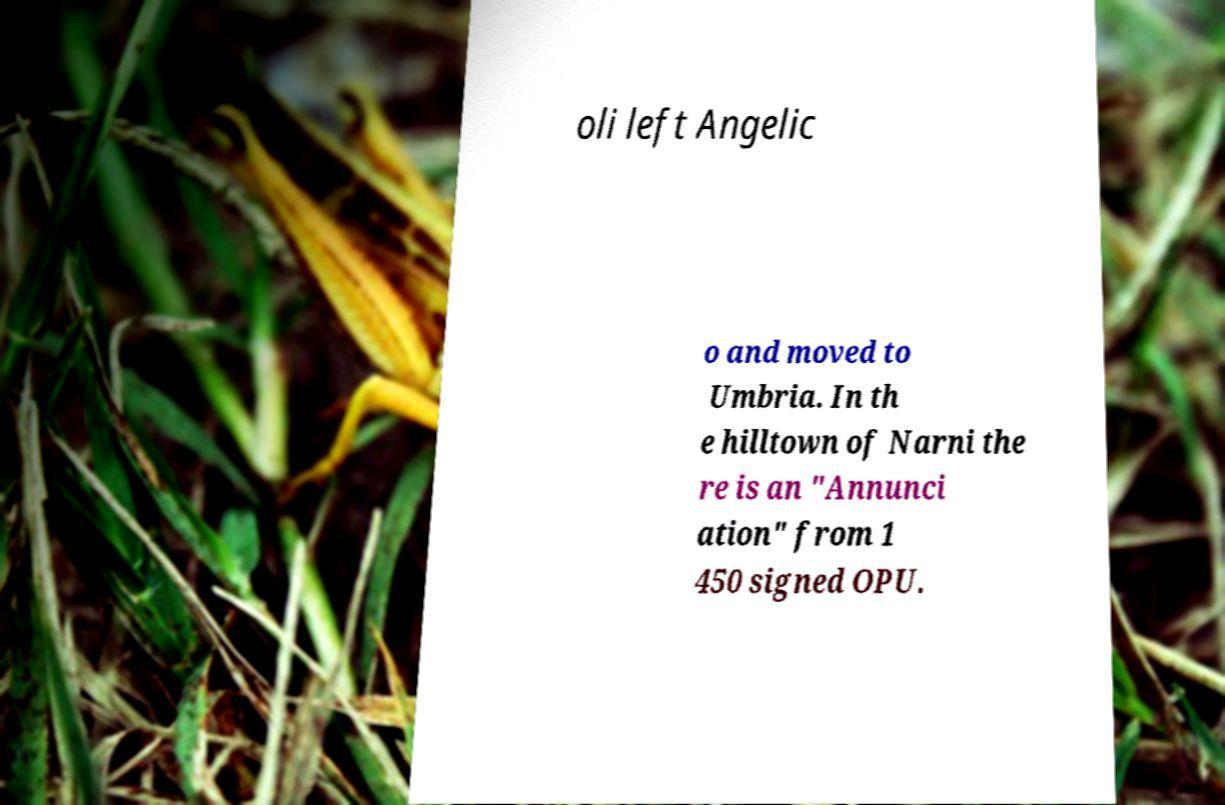Can you accurately transcribe the text from the provided image for me? oli left Angelic o and moved to Umbria. In th e hilltown of Narni the re is an "Annunci ation" from 1 450 signed OPU. 